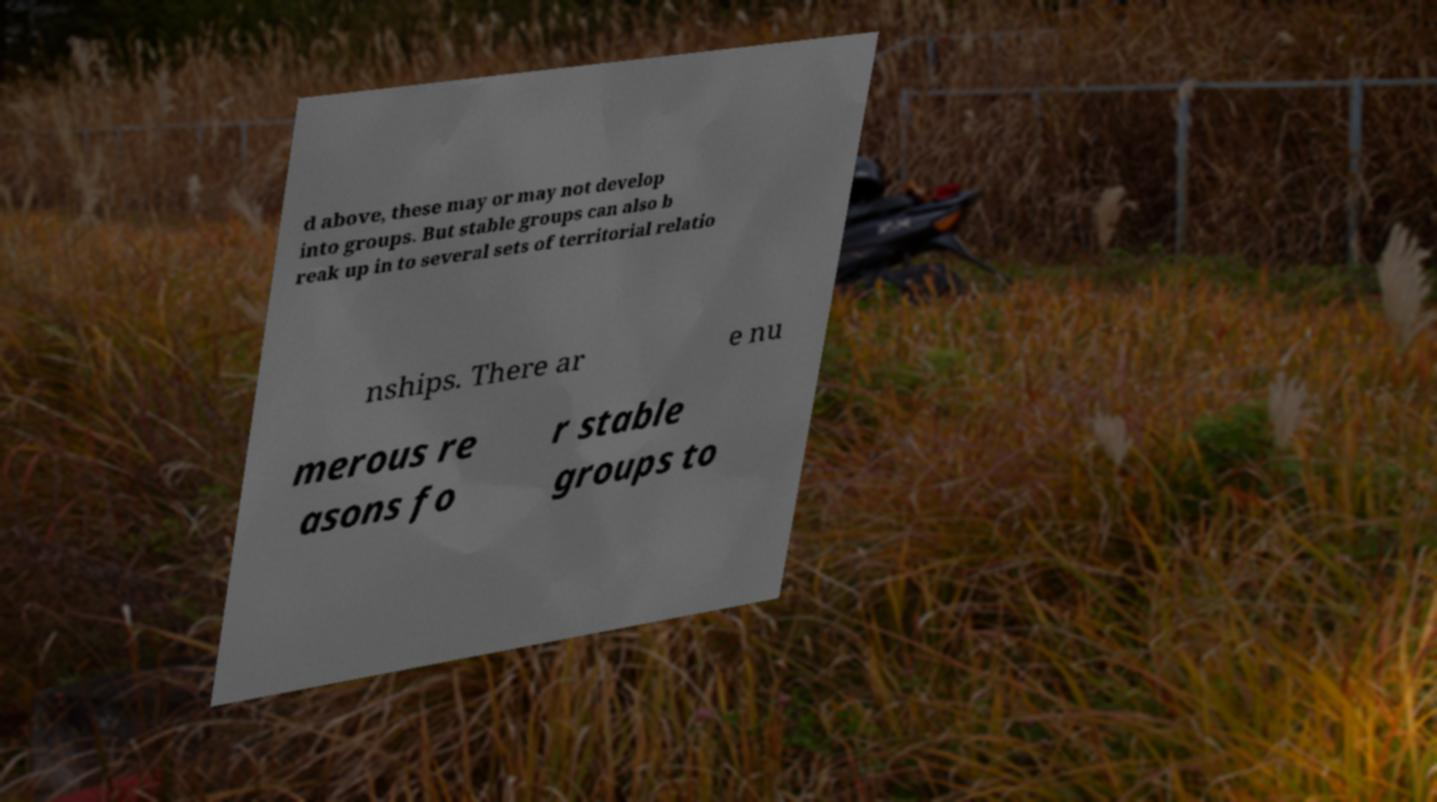Could you assist in decoding the text presented in this image and type it out clearly? d above, these may or may not develop into groups. But stable groups can also b reak up in to several sets of territorial relatio nships. There ar e nu merous re asons fo r stable groups to 